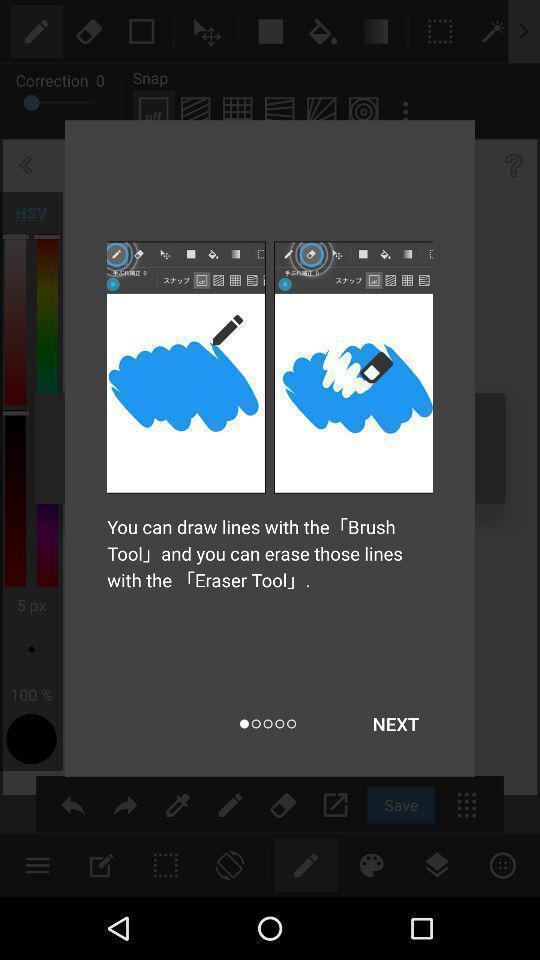Tell me what you see in this picture. Popup of drawing instructions in mobile application. 